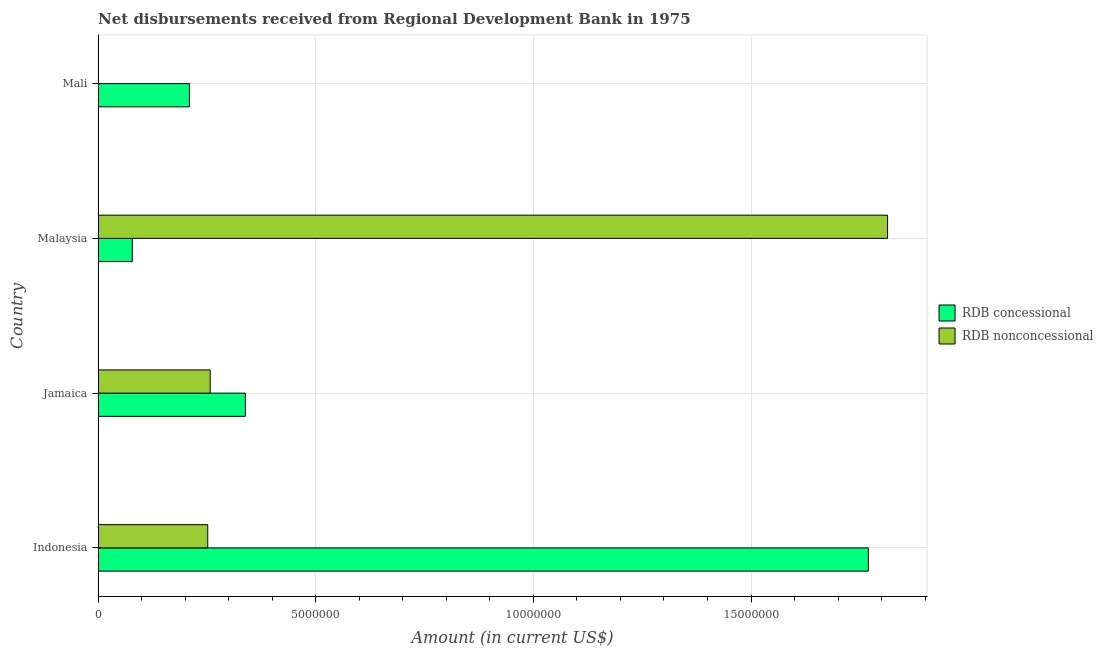Are the number of bars on each tick of the Y-axis equal?
Ensure brevity in your answer.  No. What is the label of the 2nd group of bars from the top?
Your response must be concise. Malaysia. In how many cases, is the number of bars for a given country not equal to the number of legend labels?
Your answer should be very brief. 1. What is the net concessional disbursements from rdb in Indonesia?
Your answer should be compact. 1.77e+07. Across all countries, what is the maximum net non concessional disbursements from rdb?
Your answer should be very brief. 1.81e+07. In which country was the net non concessional disbursements from rdb maximum?
Provide a succinct answer. Malaysia. What is the total net concessional disbursements from rdb in the graph?
Offer a very short reply. 2.40e+07. What is the difference between the net non concessional disbursements from rdb in Jamaica and that in Malaysia?
Your response must be concise. -1.56e+07. What is the difference between the net concessional disbursements from rdb in Mali and the net non concessional disbursements from rdb in Jamaica?
Your response must be concise. -4.77e+05. What is the average net concessional disbursements from rdb per country?
Offer a very short reply. 5.99e+06. What is the difference between the net non concessional disbursements from rdb and net concessional disbursements from rdb in Jamaica?
Provide a succinct answer. -8.08e+05. In how many countries, is the net concessional disbursements from rdb greater than 13000000 US$?
Keep it short and to the point. 1. What is the ratio of the net concessional disbursements from rdb in Indonesia to that in Malaysia?
Give a very brief answer. 22.54. Is the difference between the net non concessional disbursements from rdb in Indonesia and Malaysia greater than the difference between the net concessional disbursements from rdb in Indonesia and Malaysia?
Your answer should be compact. No. What is the difference between the highest and the second highest net non concessional disbursements from rdb?
Provide a short and direct response. 1.56e+07. What is the difference between the highest and the lowest net concessional disbursements from rdb?
Make the answer very short. 1.69e+07. In how many countries, is the net concessional disbursements from rdb greater than the average net concessional disbursements from rdb taken over all countries?
Provide a succinct answer. 1. How many bars are there?
Offer a terse response. 7. How many countries are there in the graph?
Make the answer very short. 4. What is the difference between two consecutive major ticks on the X-axis?
Provide a short and direct response. 5.00e+06. Are the values on the major ticks of X-axis written in scientific E-notation?
Keep it short and to the point. No. Does the graph contain any zero values?
Keep it short and to the point. Yes. Does the graph contain grids?
Your response must be concise. Yes. How many legend labels are there?
Keep it short and to the point. 2. What is the title of the graph?
Your answer should be very brief. Net disbursements received from Regional Development Bank in 1975. What is the label or title of the X-axis?
Give a very brief answer. Amount (in current US$). What is the Amount (in current US$) in RDB concessional in Indonesia?
Give a very brief answer. 1.77e+07. What is the Amount (in current US$) in RDB nonconcessional in Indonesia?
Your answer should be compact. 2.52e+06. What is the Amount (in current US$) in RDB concessional in Jamaica?
Ensure brevity in your answer.  3.38e+06. What is the Amount (in current US$) in RDB nonconcessional in Jamaica?
Keep it short and to the point. 2.58e+06. What is the Amount (in current US$) of RDB concessional in Malaysia?
Your answer should be very brief. 7.85e+05. What is the Amount (in current US$) of RDB nonconcessional in Malaysia?
Offer a terse response. 1.81e+07. What is the Amount (in current US$) in RDB concessional in Mali?
Your response must be concise. 2.10e+06. Across all countries, what is the maximum Amount (in current US$) in RDB concessional?
Keep it short and to the point. 1.77e+07. Across all countries, what is the maximum Amount (in current US$) of RDB nonconcessional?
Your answer should be very brief. 1.81e+07. Across all countries, what is the minimum Amount (in current US$) of RDB concessional?
Your answer should be very brief. 7.85e+05. Across all countries, what is the minimum Amount (in current US$) in RDB nonconcessional?
Provide a succinct answer. 0. What is the total Amount (in current US$) in RDB concessional in the graph?
Your answer should be compact. 2.40e+07. What is the total Amount (in current US$) in RDB nonconcessional in the graph?
Your answer should be compact. 2.32e+07. What is the difference between the Amount (in current US$) of RDB concessional in Indonesia and that in Jamaica?
Make the answer very short. 1.43e+07. What is the difference between the Amount (in current US$) of RDB nonconcessional in Indonesia and that in Jamaica?
Offer a terse response. -5.60e+04. What is the difference between the Amount (in current US$) in RDB concessional in Indonesia and that in Malaysia?
Give a very brief answer. 1.69e+07. What is the difference between the Amount (in current US$) of RDB nonconcessional in Indonesia and that in Malaysia?
Ensure brevity in your answer.  -1.56e+07. What is the difference between the Amount (in current US$) in RDB concessional in Indonesia and that in Mali?
Provide a succinct answer. 1.56e+07. What is the difference between the Amount (in current US$) of RDB concessional in Jamaica and that in Malaysia?
Provide a short and direct response. 2.60e+06. What is the difference between the Amount (in current US$) in RDB nonconcessional in Jamaica and that in Malaysia?
Your response must be concise. -1.56e+07. What is the difference between the Amount (in current US$) in RDB concessional in Jamaica and that in Mali?
Keep it short and to the point. 1.28e+06. What is the difference between the Amount (in current US$) in RDB concessional in Malaysia and that in Mali?
Your answer should be very brief. -1.31e+06. What is the difference between the Amount (in current US$) in RDB concessional in Indonesia and the Amount (in current US$) in RDB nonconcessional in Jamaica?
Keep it short and to the point. 1.51e+07. What is the difference between the Amount (in current US$) of RDB concessional in Indonesia and the Amount (in current US$) of RDB nonconcessional in Malaysia?
Ensure brevity in your answer.  -4.41e+05. What is the difference between the Amount (in current US$) of RDB concessional in Jamaica and the Amount (in current US$) of RDB nonconcessional in Malaysia?
Your answer should be compact. -1.48e+07. What is the average Amount (in current US$) in RDB concessional per country?
Provide a succinct answer. 5.99e+06. What is the average Amount (in current US$) of RDB nonconcessional per country?
Offer a terse response. 5.81e+06. What is the difference between the Amount (in current US$) in RDB concessional and Amount (in current US$) in RDB nonconcessional in Indonesia?
Your answer should be compact. 1.52e+07. What is the difference between the Amount (in current US$) in RDB concessional and Amount (in current US$) in RDB nonconcessional in Jamaica?
Make the answer very short. 8.08e+05. What is the difference between the Amount (in current US$) of RDB concessional and Amount (in current US$) of RDB nonconcessional in Malaysia?
Provide a short and direct response. -1.74e+07. What is the ratio of the Amount (in current US$) of RDB concessional in Indonesia to that in Jamaica?
Offer a very short reply. 5.23. What is the ratio of the Amount (in current US$) in RDB nonconcessional in Indonesia to that in Jamaica?
Keep it short and to the point. 0.98. What is the ratio of the Amount (in current US$) in RDB concessional in Indonesia to that in Malaysia?
Provide a succinct answer. 22.54. What is the ratio of the Amount (in current US$) of RDB nonconcessional in Indonesia to that in Malaysia?
Give a very brief answer. 0.14. What is the ratio of the Amount (in current US$) in RDB concessional in Indonesia to that in Mali?
Keep it short and to the point. 8.44. What is the ratio of the Amount (in current US$) in RDB concessional in Jamaica to that in Malaysia?
Ensure brevity in your answer.  4.31. What is the ratio of the Amount (in current US$) of RDB nonconcessional in Jamaica to that in Malaysia?
Your answer should be very brief. 0.14. What is the ratio of the Amount (in current US$) of RDB concessional in Jamaica to that in Mali?
Your answer should be very brief. 1.61. What is the ratio of the Amount (in current US$) of RDB concessional in Malaysia to that in Mali?
Your answer should be very brief. 0.37. What is the difference between the highest and the second highest Amount (in current US$) in RDB concessional?
Your answer should be compact. 1.43e+07. What is the difference between the highest and the second highest Amount (in current US$) in RDB nonconcessional?
Ensure brevity in your answer.  1.56e+07. What is the difference between the highest and the lowest Amount (in current US$) in RDB concessional?
Keep it short and to the point. 1.69e+07. What is the difference between the highest and the lowest Amount (in current US$) in RDB nonconcessional?
Keep it short and to the point. 1.81e+07. 